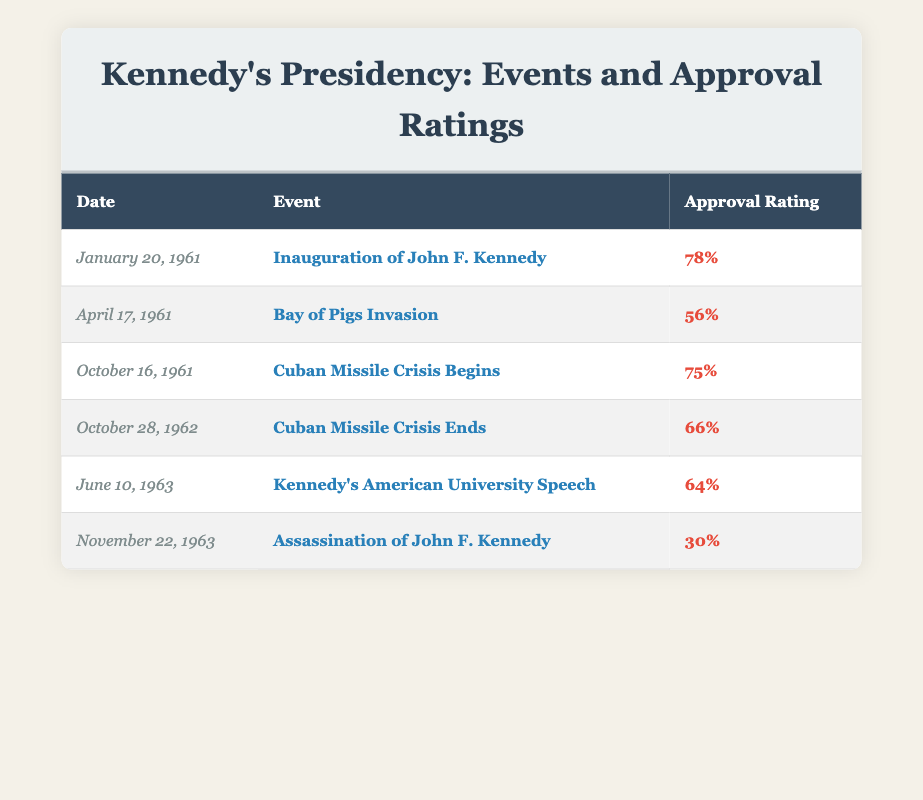What was President Kennedy's approval rating on the day of his inauguration? The table shows that on January 20, 1961, the event is the Inauguration of John F. Kennedy, with an approval rating of 78%.
Answer: 78% What was the approval rating after the Bay of Pigs Invasion? According to the table, the Bay of Pigs Invasion occurred on April 17, 1961, and the approval rating fell to 56%.
Answer: 56% What was the change in approval rating from the Bay of Pigs Invasion to the Cuban Missile Crisis Begins? The approval rating for the Bay of Pigs Invasion is 56%, and for the Cuban Missile Crisis Begins on October 16, 1962, it is 75%. The change is calculated as 75 - 56 = 19.
Answer: 19 What was the lowest approval rating recorded in the table? The table indicates that the lowest approval rating recorded is 30%, which occurred after the Assassination of John F. Kennedy on November 22, 1963.
Answer: 30% Was the approval rating higher after the Cuban Missile Crisis ended compared to Kennedy's American University Speech? The table shows that after the Cuban Missile Crisis ended, the approval rating was 66%, while Kennedy's American University Speech had an approval rating of 64%. Since 66 is greater than 64, the answer is yes.
Answer: Yes What was the average approval rating during the key events listed in the table? The approval ratings for the events are 78, 56, 75, 66, 64, and 30. Adding these gives a sum of 369, and there are 6 events. The average is then calculated by dividing the sum by the number of events: 369/6 = 61.5.
Answer: 61.5 How many events had an approval rating above 60%? Referring to the table, the events with approval ratings above 60% are: Inauguration (78%), Cuban Missile Crisis Begins (75%), Cuban Missile Crisis Ends (66%), and Kennedy's Speech (64%). This gives a total of 4 events.
Answer: 4 Which event had the highest approval rating, and what was that rating? The Inauguration of John F. Kennedy on January 20, 1961, had the highest approval rating of 78%, as indicated in the table.
Answer: 78% 